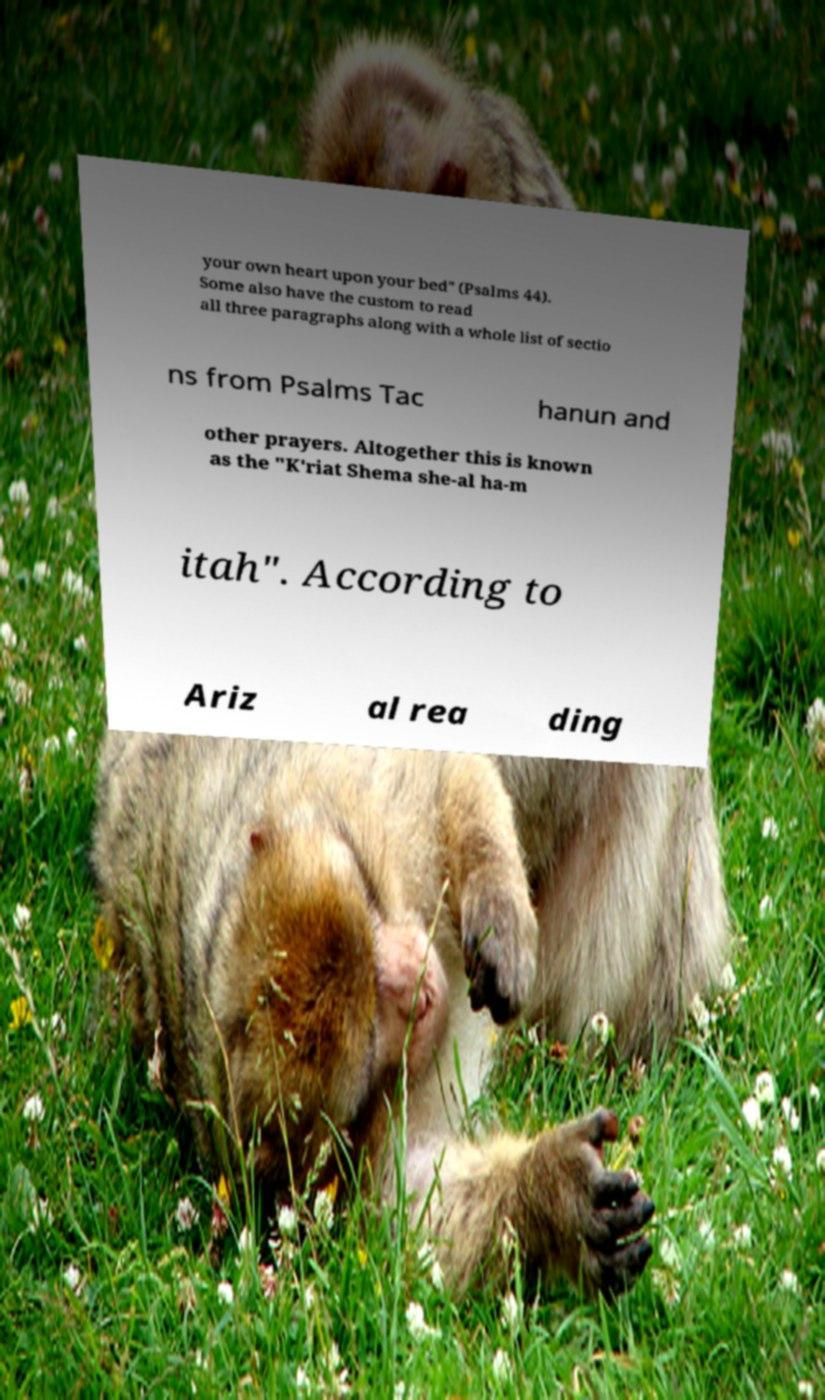Could you extract and type out the text from this image? your own heart upon your bed" (Psalms 44). Some also have the custom to read all three paragraphs along with a whole list of sectio ns from Psalms Tac hanun and other prayers. Altogether this is known as the "K'riat Shema she-al ha-m itah". According to Ariz al rea ding 